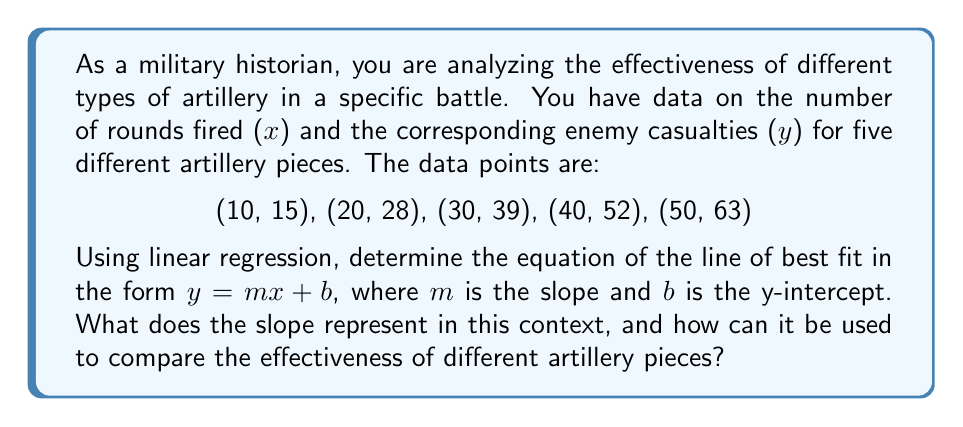Solve this math problem. To find the line of best fit using linear regression, we need to calculate the slope $m$ and y-intercept $b$ using the following formulas:

$$m = \frac{n\sum xy - \sum x \sum y}{n\sum x^2 - (\sum x)^2}$$

$$b = \frac{\sum y - m\sum x}{n}$$

Where $n$ is the number of data points.

Step 1: Calculate the necessary sums:
$n = 5$
$\sum x = 10 + 20 + 30 + 40 + 50 = 150$
$\sum y = 15 + 28 + 39 + 52 + 63 = 197$
$\sum xy = 10(15) + 20(28) + 30(39) + 40(52) + 50(63) = 6,670$
$\sum x^2 = 10^2 + 20^2 + 30^2 + 40^2 + 50^2 = 5,500$

Step 2: Calculate the slope $m$:
$$m = \frac{5(6,670) - 150(197)}{5(5,500) - 150^2} = \frac{33,350 - 29,550}{27,500 - 22,500} = \frac{3,800}{5,000} = 0.76$$

Step 3: Calculate the y-intercept $b$:
$$b = \frac{197 - 0.76(150)}{5} = \frac{197 - 114}{5} = \frac{83}{5} = 16.6$$

Therefore, the equation of the line of best fit is:

$$y = 0.76x + 16.6$$

The slope $m = 0.76$ represents the average increase in enemy casualties for each additional round fired. This can be interpreted as the effectiveness of the artillery in terms of casualties per round.

To compare the effectiveness of different artillery pieces, you can perform similar analyses for each type and compare their slopes. A higher slope indicates a more effective artillery piece, as it causes more casualties per round fired.
Answer: The equation of the line of best fit is $y = 0.76x + 16.6$. The slope $m = 0.76$ represents the average increase in enemy casualties per round fired, which can be used as a measure of artillery effectiveness for comparison between different pieces. 